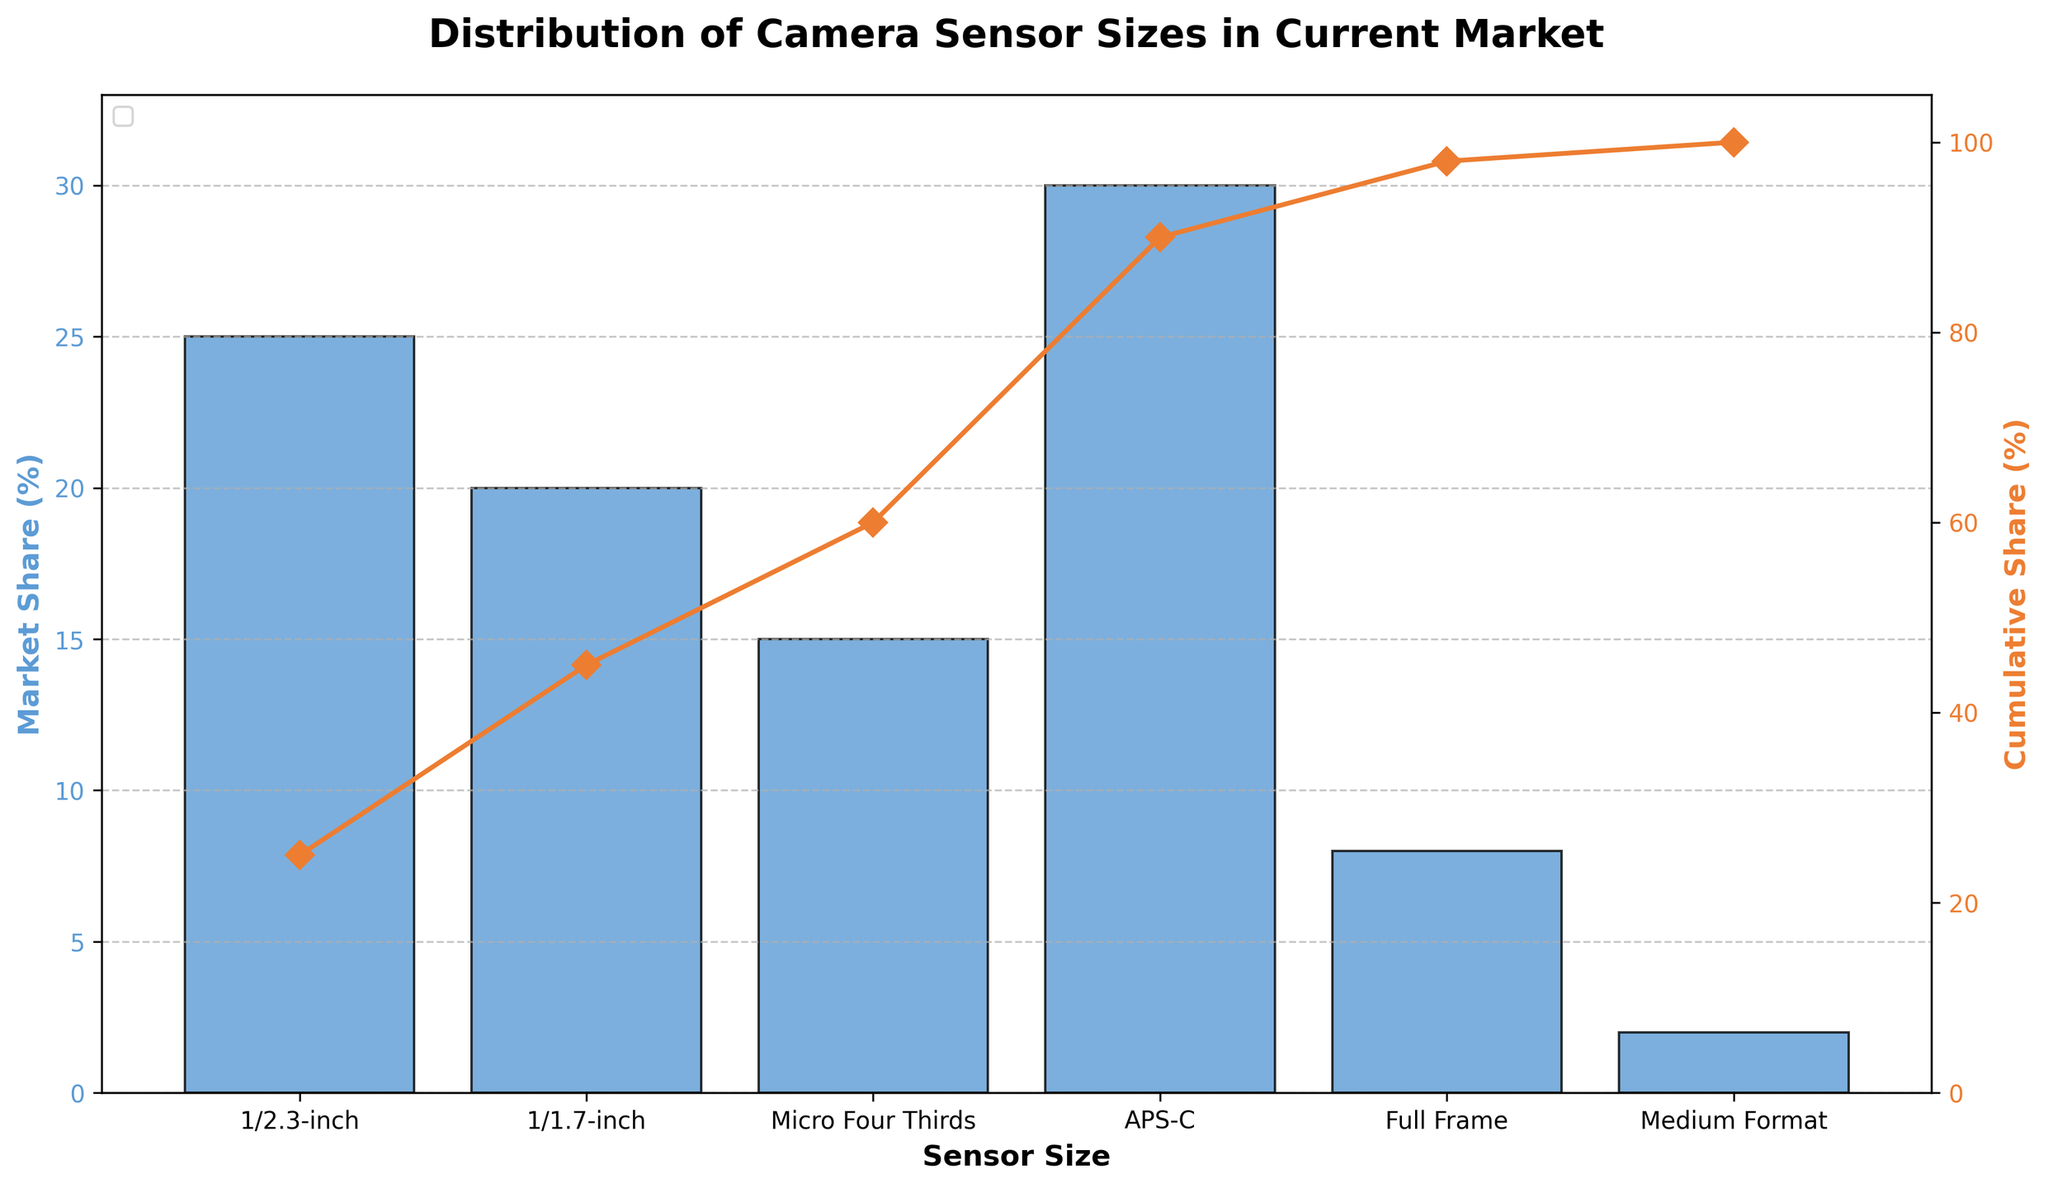What is the title of the chart? The title of the chart is displayed at the top of the figure. It reads "Distribution of Camera Sensor Sizes in Current Market."
Answer: Distribution of Camera Sensor Sizes in Current Market Which sensor size has the highest market share? By looking at the height of the bars, the sensor size with the highest market share is APS-C.
Answer: APS-C How much market share does the smallest sensor size have? The first bar represents the 1/2.3-inch sensor size, and its height indicates a market share of 25%.
Answer: 25% What is the cumulative market share up to APS-C? To find the cumulative market share up to APS-C, sum the market shares of 1/2.3-inch (25%), 1/1.7-inch (20%), Micro Four Thirds (15%), and APS-C (30%). This gives 25 + 20 + 15 + 30 = 90%.
Answer: 90% Which sensor size contributes the least to the market share? The smallest bar represents the sensor size contributing the least, which is Medium Format.
Answer: Medium Format How many sensor sizes are represented in the chart? Count the number of distinct bars along the x-axis to determine the number of sensor sizes, which is six.
Answer: 6 What is the cumulative market share for the three smallest sensor sizes? Sum the market shares of 1/2.3-inch (25%), 1/1.7-inch (20%), and Micro Four Thirds (15%). This gives 25 + 20 + 15 = 60%.
Answer: 60% Between APS-C and Full Frame, which has a higher market share and by how much? APS-C has a market share of 30%, and Full Frame has a market share of 8%. The difference is 30% - 8% = 22%.
Answer: APS-C by 22% What percentage of the market do sensor sizes smaller than APS-C hold? Sum the market shares of 1/2.3-inch (25%), 1/1.7-inch (20%), and Micro Four Thirds (15%). This gives 25 + 20 + 15 = 60%.
Answer: 60% Which sensor sizes comprise more than 50% of the total market share? By observing the cumulative share line, the sensor sizes up to and including Micro Four Thirds (1/2.3-inch, 1/1.7-inch, Micro Four Thirds) make up more than 50% of the market.
Answer: 1/2.3-inch, 1/1.7-inch, Micro Four Thirds 